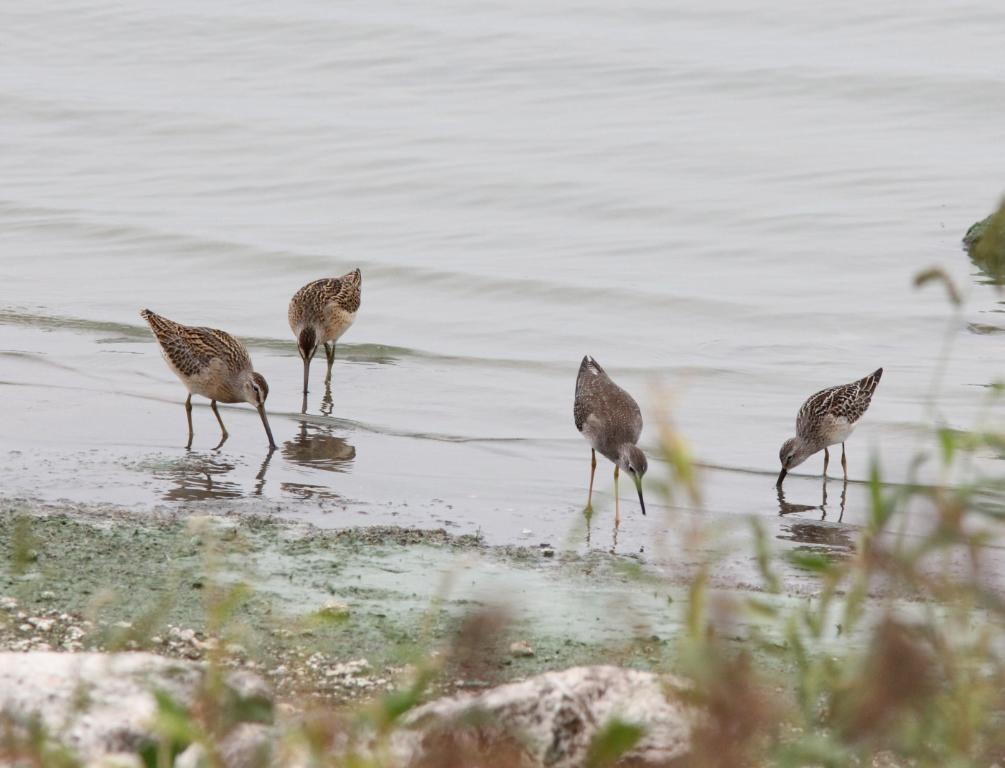What type of animals can be seen on the ground in the image? There are birds on the ground in the image. What other elements can be seen in the image besides the birds? There are plants, water, and stones visible in the image. What type of mist can be seen surrounding the snakes in the image? There are no snakes or mist present in the image; it features birds, plants, water, and stones. 